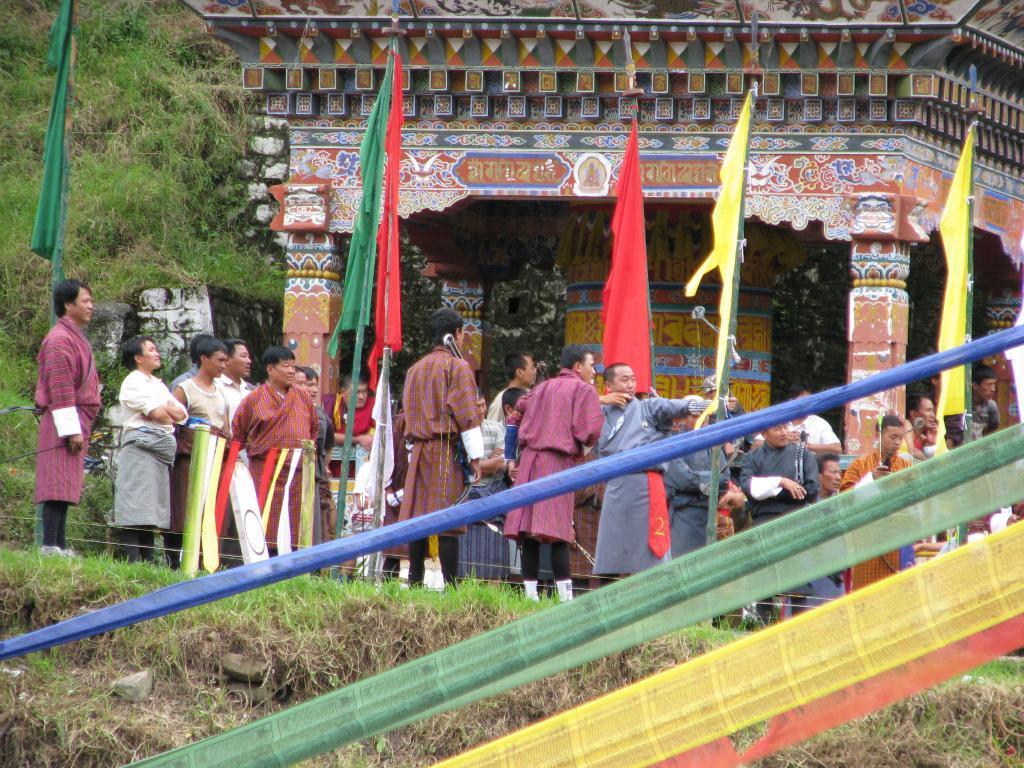Describe this image in one or two sentences. In this image we can see a few people, flags, poles, clothes, and a temple, there are some plants, grass. 